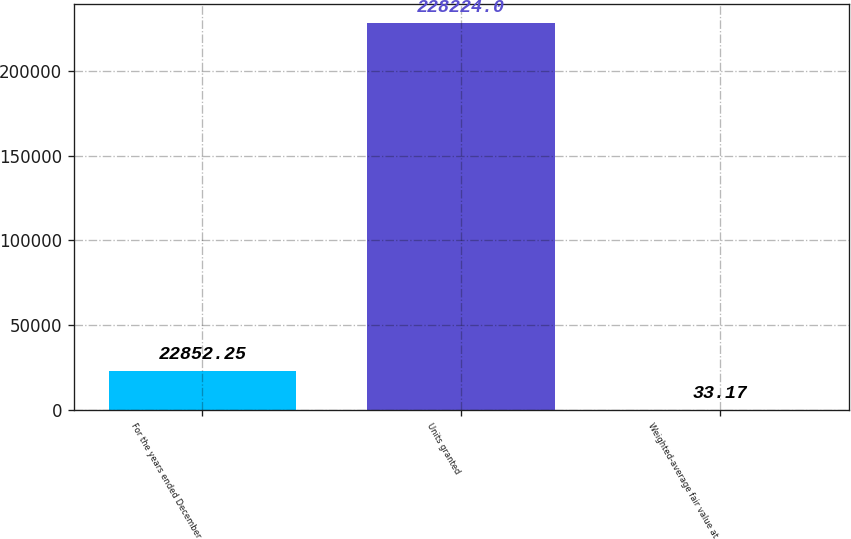Convert chart to OTSL. <chart><loc_0><loc_0><loc_500><loc_500><bar_chart><fcel>For the years ended December<fcel>Units granted<fcel>Weighted-average fair value at<nl><fcel>22852.2<fcel>228224<fcel>33.17<nl></chart> 